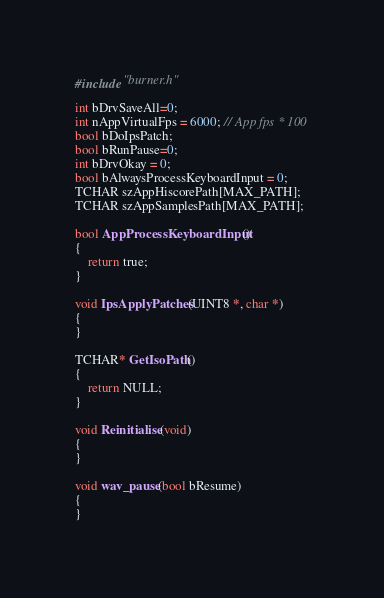<code> <loc_0><loc_0><loc_500><loc_500><_C++_>#include "burner.h"

int bDrvSaveAll=0;
int nAppVirtualFps = 6000; // App fps * 100
bool bDoIpsPatch;
bool bRunPause=0;
int bDrvOkay = 0;
bool bAlwaysProcessKeyboardInput = 0;
TCHAR szAppHiscorePath[MAX_PATH];
TCHAR szAppSamplesPath[MAX_PATH];

bool AppProcessKeyboardInput()
{
	return true;
}

void IpsApplyPatches(UINT8 *, char *)
{
}

TCHAR* GetIsoPath()
{
    return NULL;
}

void Reinitialise(void)
{
}

void wav_pause(bool bResume)
{
}
</code> 